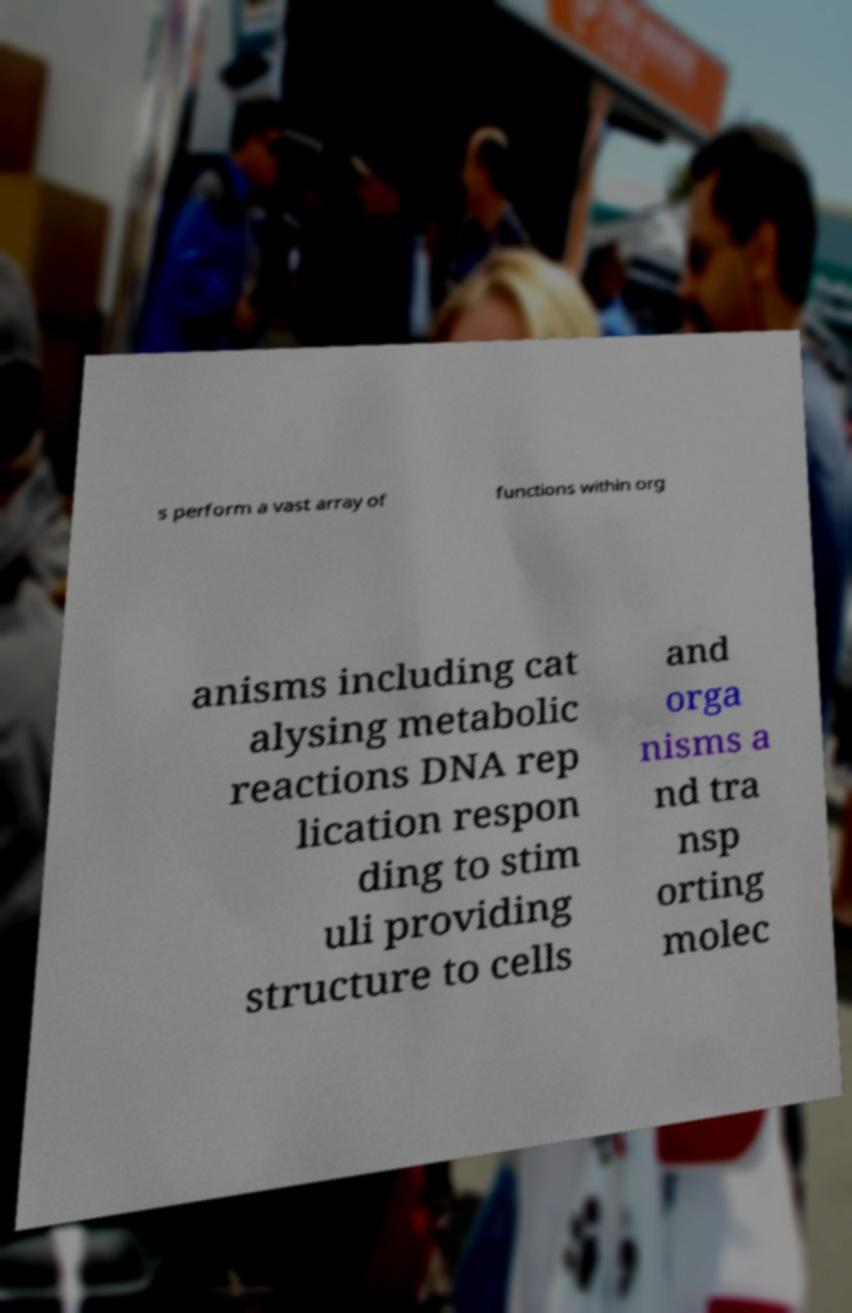Can you accurately transcribe the text from the provided image for me? s perform a vast array of functions within org anisms including cat alysing metabolic reactions DNA rep lication respon ding to stim uli providing structure to cells and orga nisms a nd tra nsp orting molec 